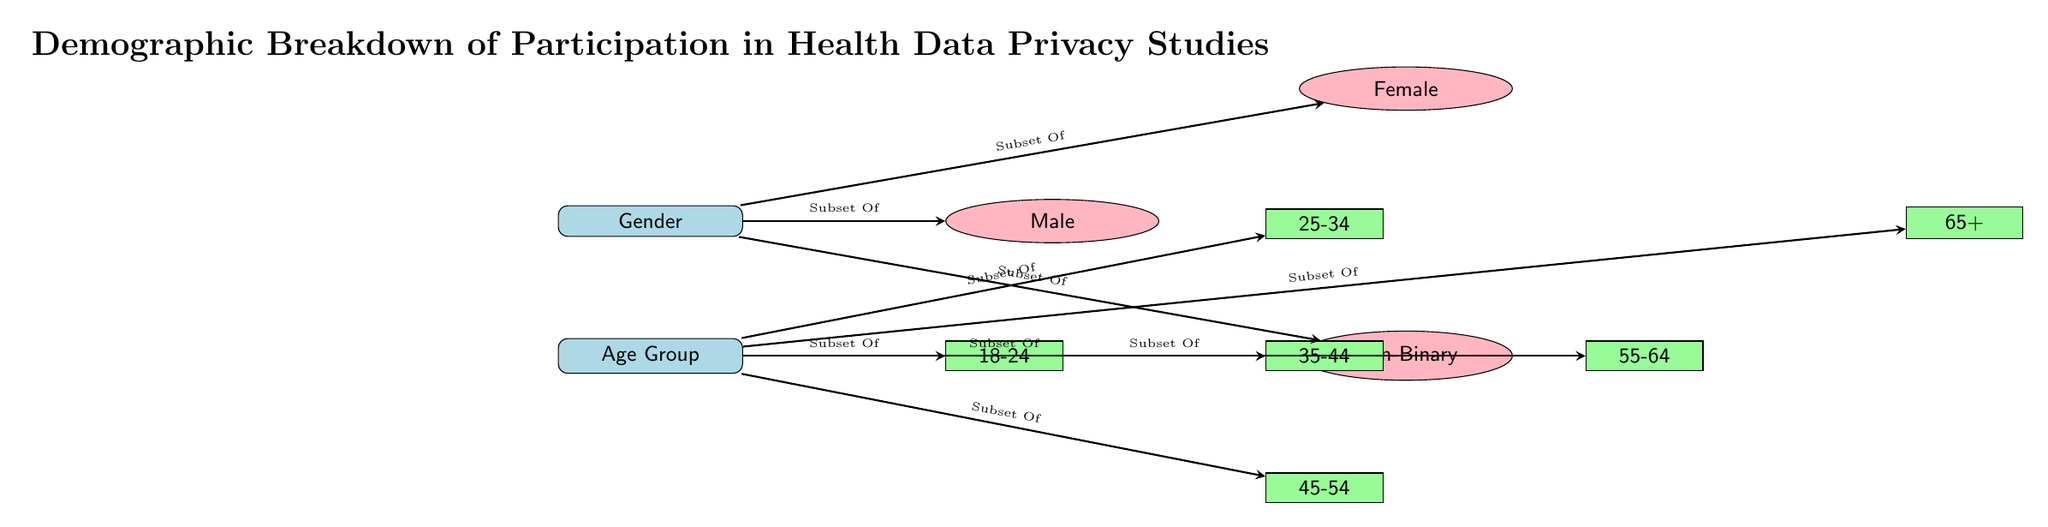What are the two main demographic categories in the diagram? The diagram presents two main categories under the title "Demographic Breakdown of Participation in Health Data Privacy Studies": Gender and Age Group. These categories are depicted as nodes at the top of the diagram.
Answer: Gender, Age Group How many gender subcategories are represented? The gender node branches into three subcategories: Male, Female, and Non-Binary. Therefore, there are three gender subcategories represented in the diagram.
Answer: 3 What is the age subcategory for participants aged 25-34? The diagram clearly shows that 25-34 is one of the age groups listed under the "Age Group" node. This age group is specifically identified as a subcategory connected directly to the Age Group node.
Answer: 25-34 Which age group follows the 45-54 age group in the diagram? The age groups are ordered in a specific sequence below the "Age Group" node. After 45-54, the next age group in descending hierarchy is 55-64, indicating the structure of age groups in the diagram.
Answer: 55-64 How many age groups are indicated in the diagram? Counting the age groups listed under "Age Group", we find six distinct groups: 18-24, 25-34, 35-44, 45-54, 55-64, and 65+. Thus, the total number of age groups indicated in the diagram is six.
Answer: 6 What is the relationship between "Gender" and "Age Group"? The "Gender" node and "Age Group" node are both categorized as demographics representing subsets of participants in the health data privacy studies. They are shown as separate but related categories, indicating a potential intersection of these attributes in study participation.
Answer: Subset Of Which demographic category shows a more detailed breakdown? The diagram provides a detailed breakdown for age groups, with six distinct subcategories compared to only three for gender. This indicates a greater diversity within the age group representation in the studies.
Answer: Age Group Is "Non-Binary" listed as a gender option? Yes, "Non-Binary" is explicitly mentioned as one of the gender options branching from the "Gender" node. This shows the inclusion of diverse gender identities in the study participation data.
Answer: Yes How are the age groups connected to their respective demographic category? Each age group is connected by arrows that denote they are subsets of the "Age Group" demographic category. These arrows illustrate that all listed age categories fall under the broader category of age demographics in health data privacy studies.
Answer: Subset Of 